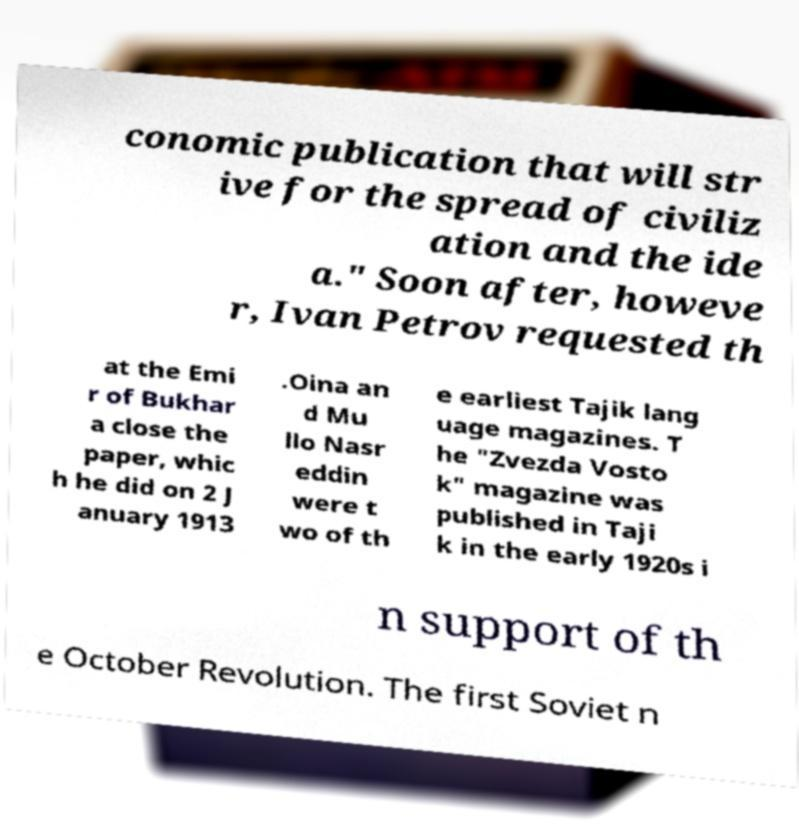I need the written content from this picture converted into text. Can you do that? conomic publication that will str ive for the spread of civiliz ation and the ide a." Soon after, howeve r, Ivan Petrov requested th at the Emi r of Bukhar a close the paper, whic h he did on 2 J anuary 1913 .Oina an d Mu llo Nasr eddin were t wo of th e earliest Tajik lang uage magazines. T he "Zvezda Vosto k" magazine was published in Taji k in the early 1920s i n support of th e October Revolution. The first Soviet n 